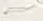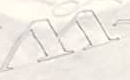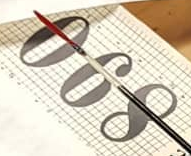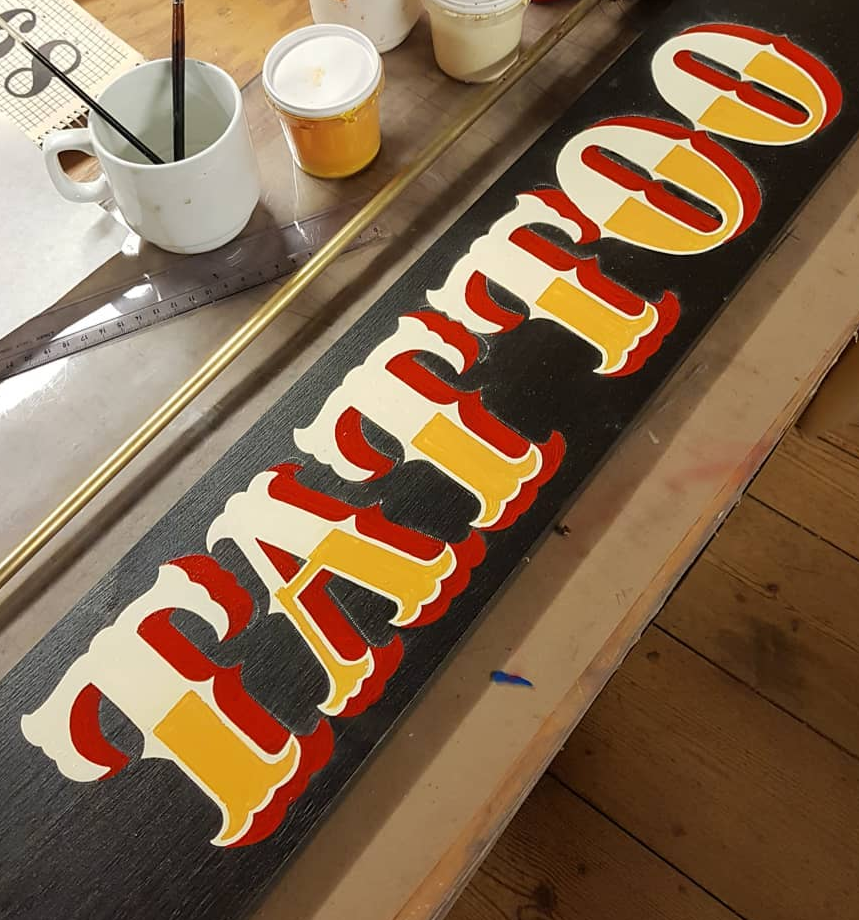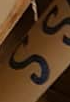Read the text content from these images in order, separated by a semicolon. ~; W; 890; TATTOO; SS 